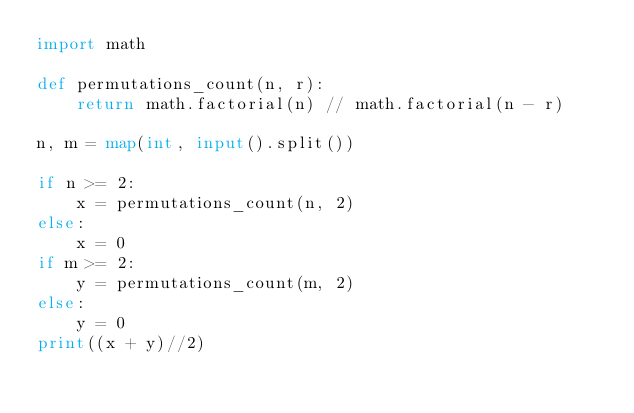Convert code to text. <code><loc_0><loc_0><loc_500><loc_500><_Python_>import math

def permutations_count(n, r):
    return math.factorial(n) // math.factorial(n - r)

n, m = map(int, input().split())

if n >= 2:
    x = permutations_count(n, 2)
else:
    x = 0
if m >= 2:
    y = permutations_count(m, 2)
else:
    y = 0
print((x + y)//2)</code> 